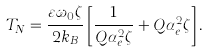Convert formula to latex. <formula><loc_0><loc_0><loc_500><loc_500>T _ { N } = \frac { \varepsilon \omega _ { 0 } \zeta } { 2 k _ { B } } \left [ \frac { 1 } { Q \alpha _ { e } ^ { 2 } \zeta } + Q \alpha _ { e } ^ { 2 } \zeta \right ] .</formula> 